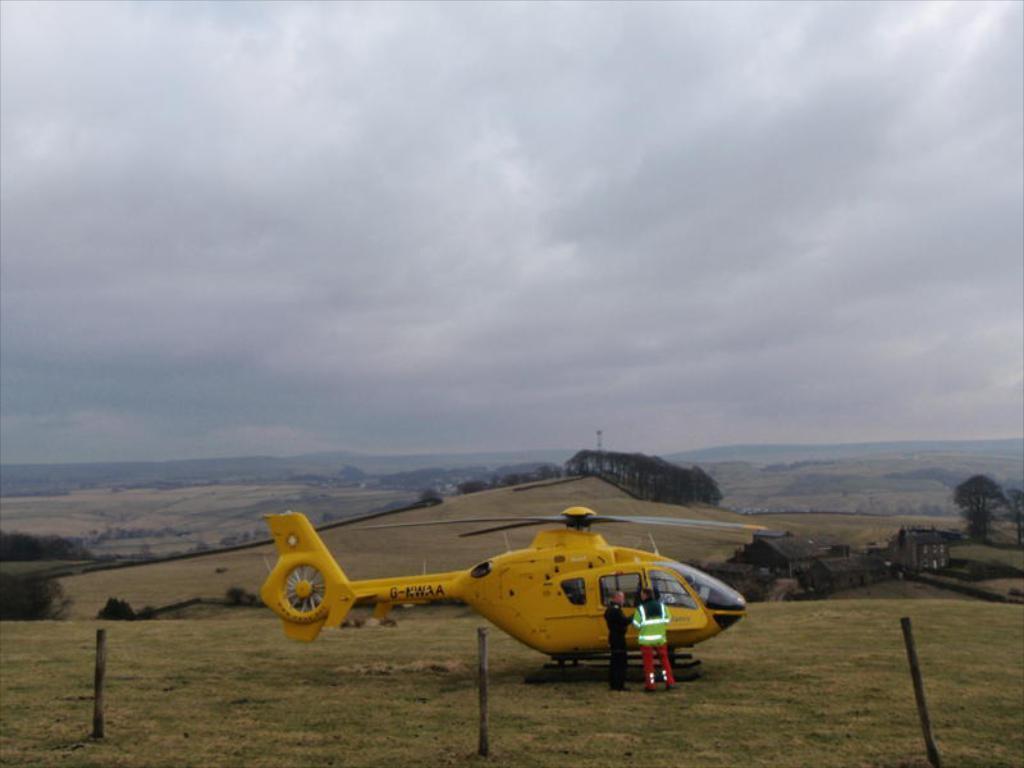How would you summarize this image in a sentence or two? In the image there is a yellow color helicopter on the grassland with two persons standing beside it and behind it there are hills covered with plants and trees and above its sky with clouds. 